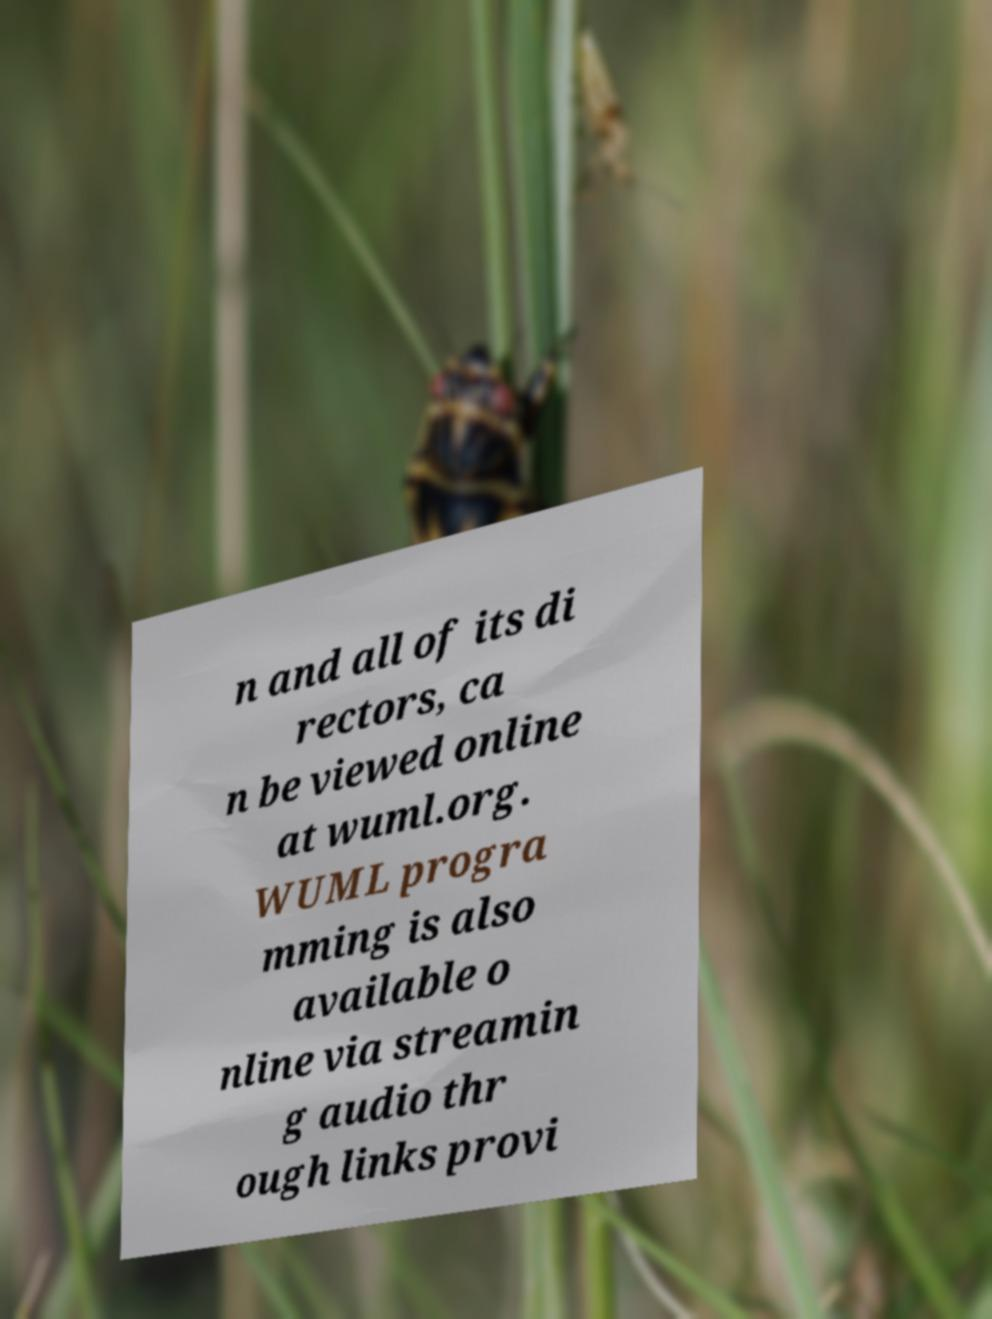Please read and relay the text visible in this image. What does it say? n and all of its di rectors, ca n be viewed online at wuml.org. WUML progra mming is also available o nline via streamin g audio thr ough links provi 